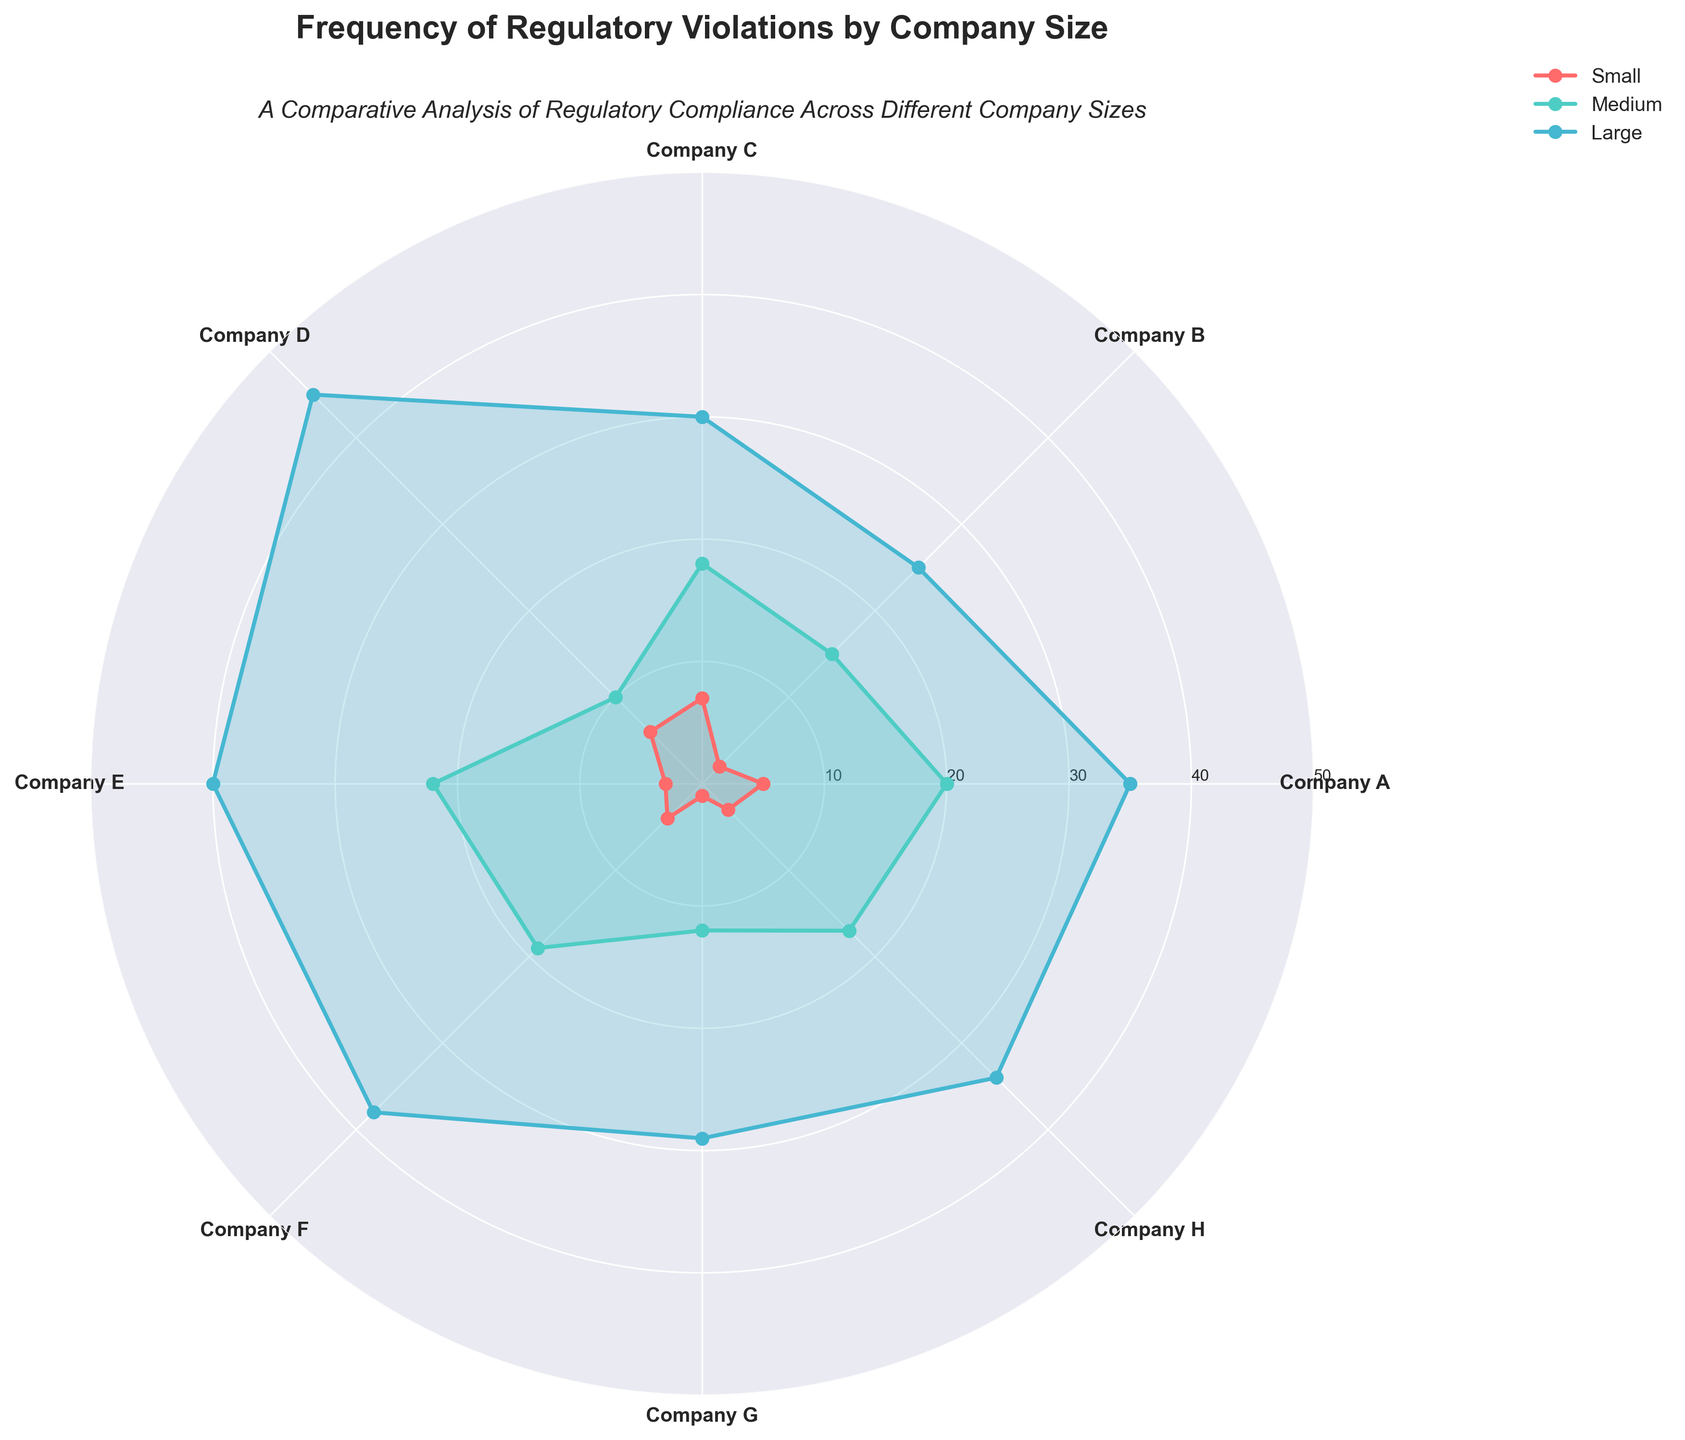What's the title of the figure? Look at the top of the plot where the title is displayed.
Answer: Frequency of Regulatory Violations by Company Size Which company has the highest number of violations in the "Large" category? Compare the values for the "Large" category for all companies and identify the highest value. Company D has the highest at 45 violations.
Answer: Company D What are the violation counts for Company C in all three categories? Identify the values for Small, Medium, and Large categories for Company C in the plot. Small: 7, Medium: 18, Large: 30.
Answer: 7, 18, 30 Calculate the average number of violations for Large companies across all data points. Sum the violations for the Large category of all companies: 35 + 25 + 30 + 45 + 40 + 38 + 29 + 34 = 276. Then divide by the number of companies (8). The average is 276 / 8 = 34.5.
Answer: 34.5 Which company has the lowest number of violations in the "Small" category and what is that value? Compare all the values in the "Small" category and identify the smallest value. Company G has the lowest with 1 violation.
Answer: Company G, 1 Compare the violations of Company E and Company F in the "Medium" category. Which one has more violations and by how much? Company E has 22 violations while Company F has 19 in the Medium category. The difference is 22 - 19 = 3.
Answer: Company E, 3 How many companies have a violation count greater than or equal to 30 in the "Large" category? Identify companies where the Large category value is 30 or more. Companies A, C, D, E, F, H meet this criterion. There are 6 companies.
Answer: 6 For Company B, what is the combined violation count for Small and Medium categories? Sum the violations in the Small and Medium categories for Company B: 2 + 15 = 17.
Answer: 17 Which category shows the greatest variation in violation counts across all companies? Evaluate the range of values (difference between highest and lowest) in each category. The Small category ranges from 1 to 7 (6), Medium from 10 to 22 (12), and Large from 25 to 45 (20). The Large category shows the greatest variation.
Answer: Large Rank the companies from highest to lowest based on their total number of violations across all three categories. Calculate the sum of violations for each company and then rank them. A: 60, B: 42, C: 55, D: 61, E: 65, F: 61, G: 42, H: 54. Ranking: E > D, F > A > C > H > B, G.
Answer: E, D, F, A, C, H, B, G 